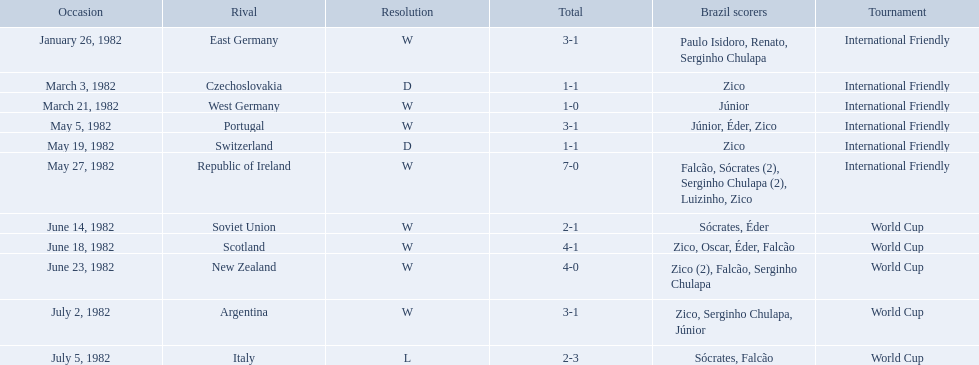What were the scores of each of game in the 1982 brazilian football games? 3-1, 1-1, 1-0, 3-1, 1-1, 7-0, 2-1, 4-1, 4-0, 3-1, 2-3. Of those, which were scores from games against portugal and the soviet union? 3-1, 2-1. And between those two games, against which country did brazil score more goals? Portugal. 